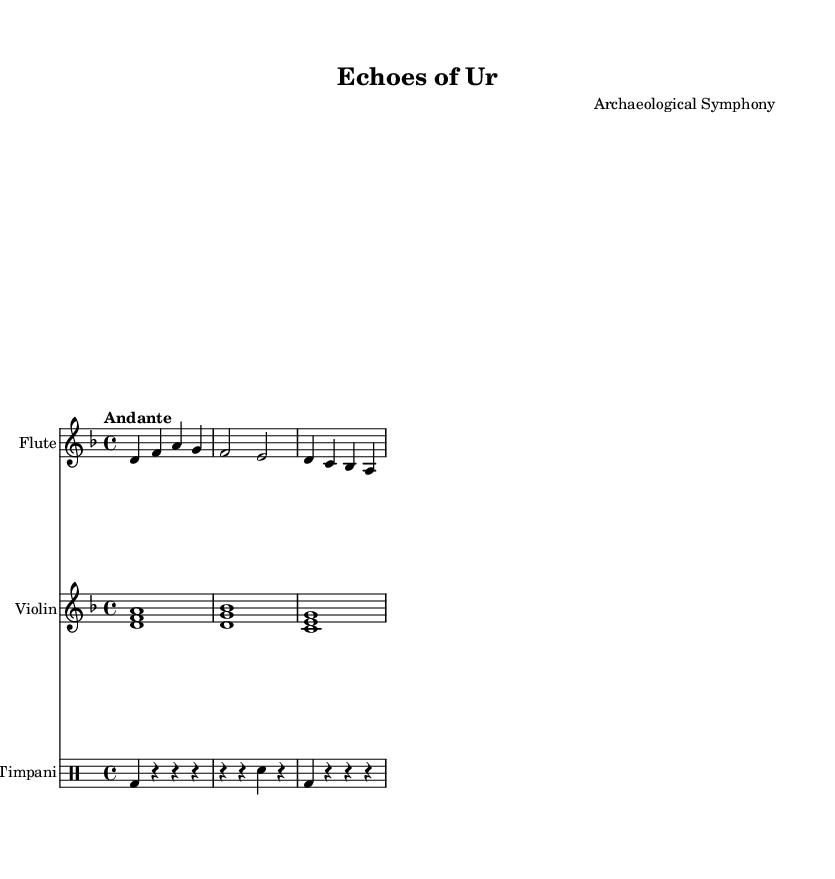What is the title of this composition? The title is indicated in the header section of the sheet music. It specifically states "Echoes of Ur."
Answer: Echoes of Ur What is the key signature of this music? The key signature is denoted by the number of sharps or flats after the clef. Here, there are no sharps or flats, which indicates it's in D minor.
Answer: D minor What is the time signature of the piece? The time signature is clearly displayed just after the clef. It shows a 4 over 4, meaning there are 4 beats per measure.
Answer: 4/4 What is the tempo marking for this piece? The tempo marking in the header section shows "Andante," which indicates a moderately slow tempo.
Answer: Andante Which instruments are used in this composition? The instruments are listed at the beginning of their respective staffs. They are Flute, Violin, and Timpani.
Answer: Flute, Violin, Timpani How many measures does the flute part contain? By counting the measures in the flute part, we see that there are a total of 3 measures present.
Answer: 3 What kind of piece is "Echoes of Ur"? Based on the title and the instruments used, it can be inferred that this piece is a symphony that likely draws inspiration from ancient civilizations or archaeology.
Answer: Symphony 